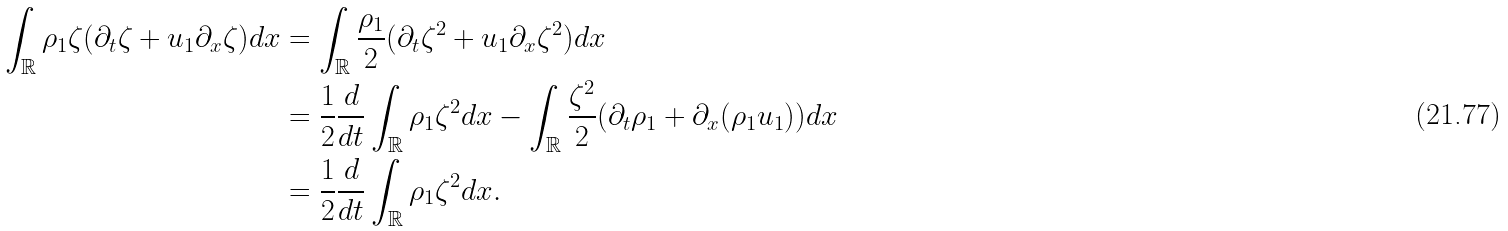Convert formula to latex. <formula><loc_0><loc_0><loc_500><loc_500>\int _ { \mathbb { R } } \rho _ { 1 } \zeta ( \partial _ { t } \zeta + u _ { 1 } \partial _ { x } \zeta ) d x & = \int _ { \mathbb { R } } \frac { \rho _ { 1 } } { 2 } ( \partial _ { t } \zeta ^ { 2 } + u _ { 1 } \partial _ { x } \zeta ^ { 2 } ) d x \\ & = \frac { 1 } { 2 } \frac { d } { d t } \int _ { \mathbb { R } } \rho _ { 1 } \zeta ^ { 2 } d x - \int _ { \mathbb { R } } \frac { \zeta ^ { 2 } } { 2 } ( \partial _ { t } \rho _ { 1 } + \partial _ { x } ( \rho _ { 1 } u _ { 1 } ) ) d x \\ & = \frac { 1 } { 2 } \frac { d } { d t } \int _ { \mathbb { R } } \rho _ { 1 } \zeta ^ { 2 } d x .</formula> 